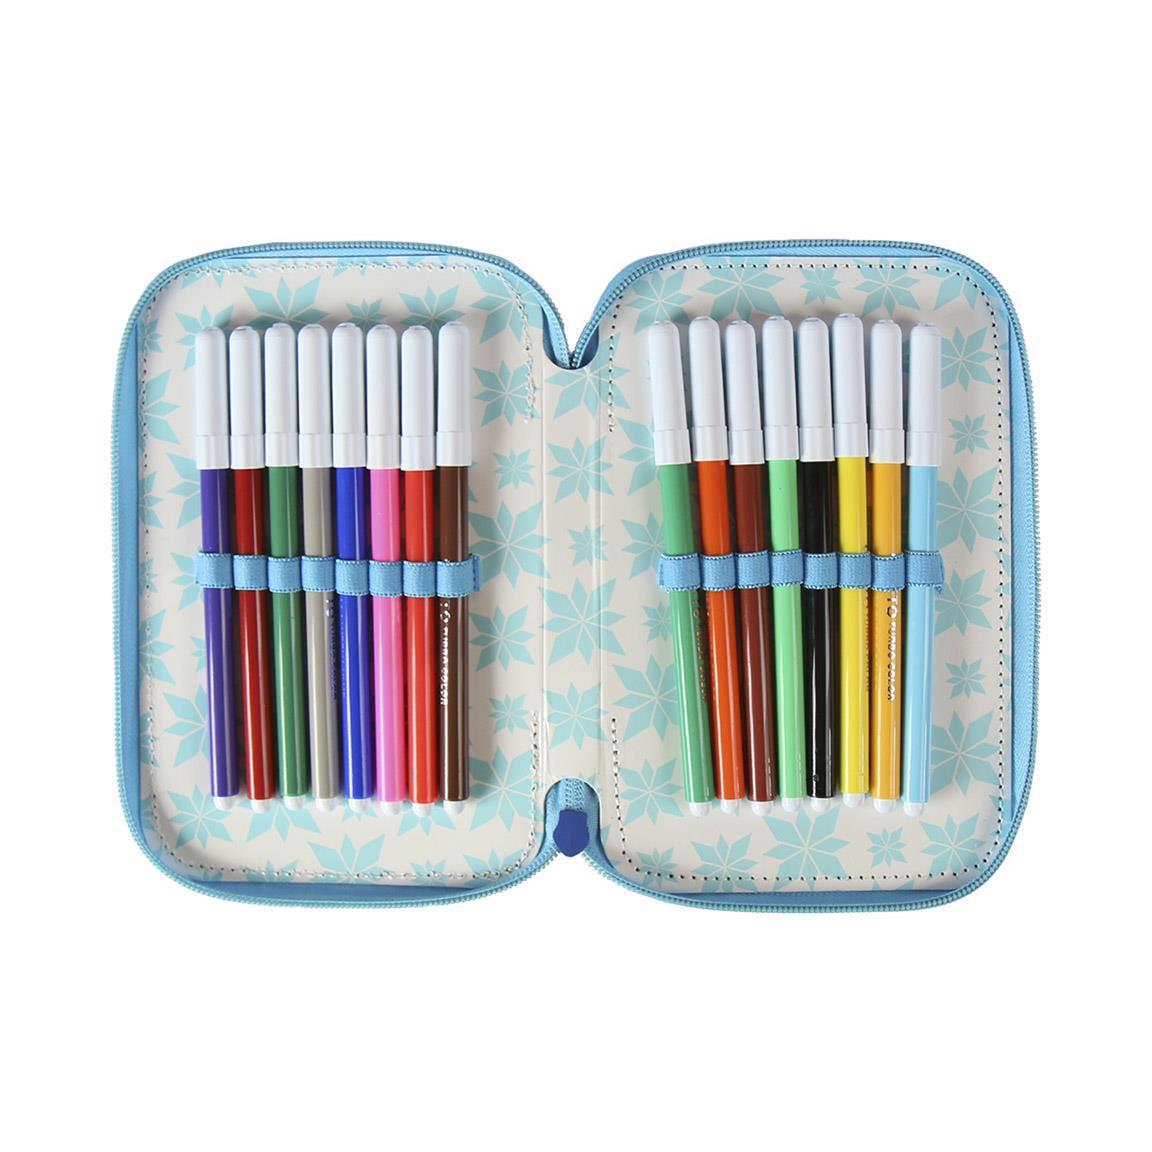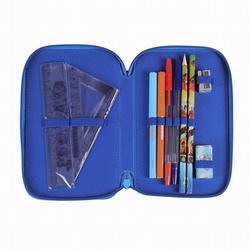The first image is the image on the left, the second image is the image on the right. For the images displayed, is the sentence "Each image shows one penicl case that opens flat, and all pencil cases contain only writing implements." factually correct? Answer yes or no. No. The first image is the image on the left, the second image is the image on the right. Examine the images to the left and right. Is the description "At least one of the pencil cases has a pencil sharpener fastened within." accurate? Answer yes or no. Yes. 